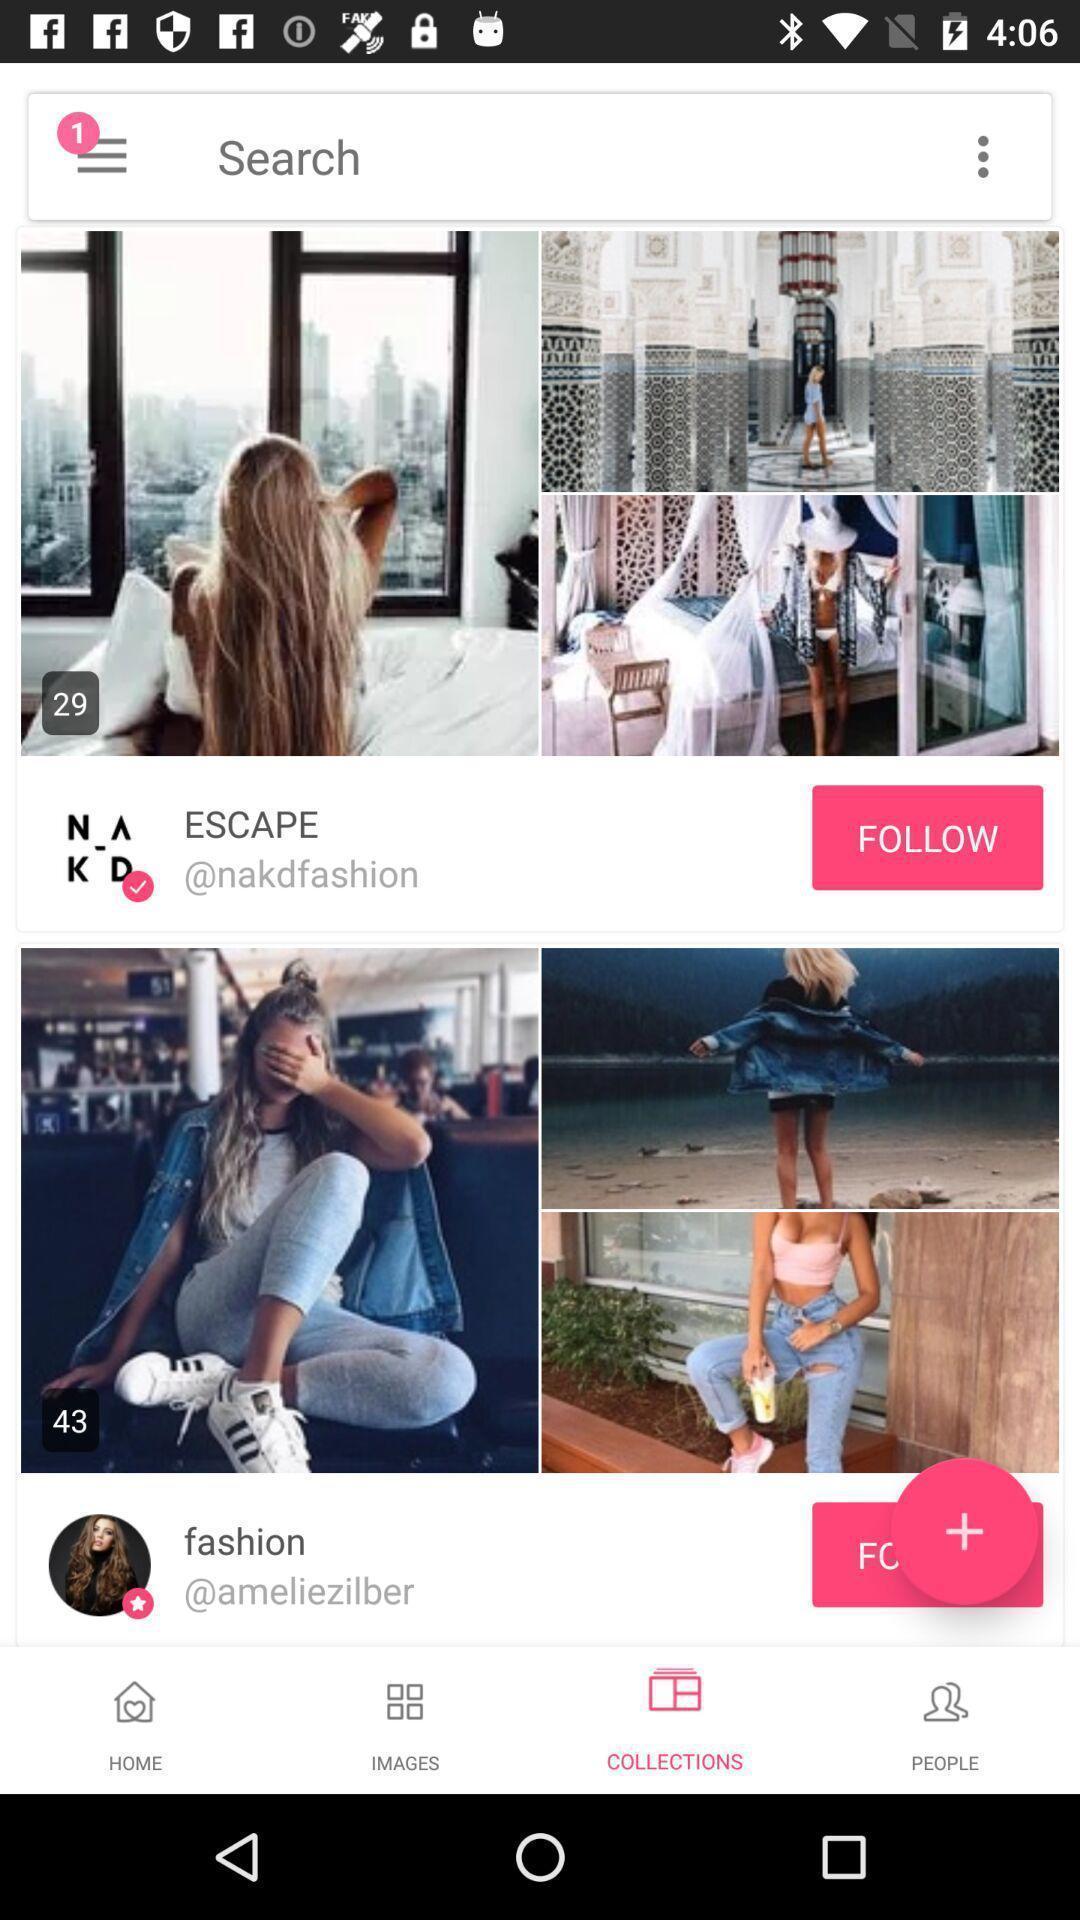Provide a detailed account of this screenshot. Various postings in a social media app. 